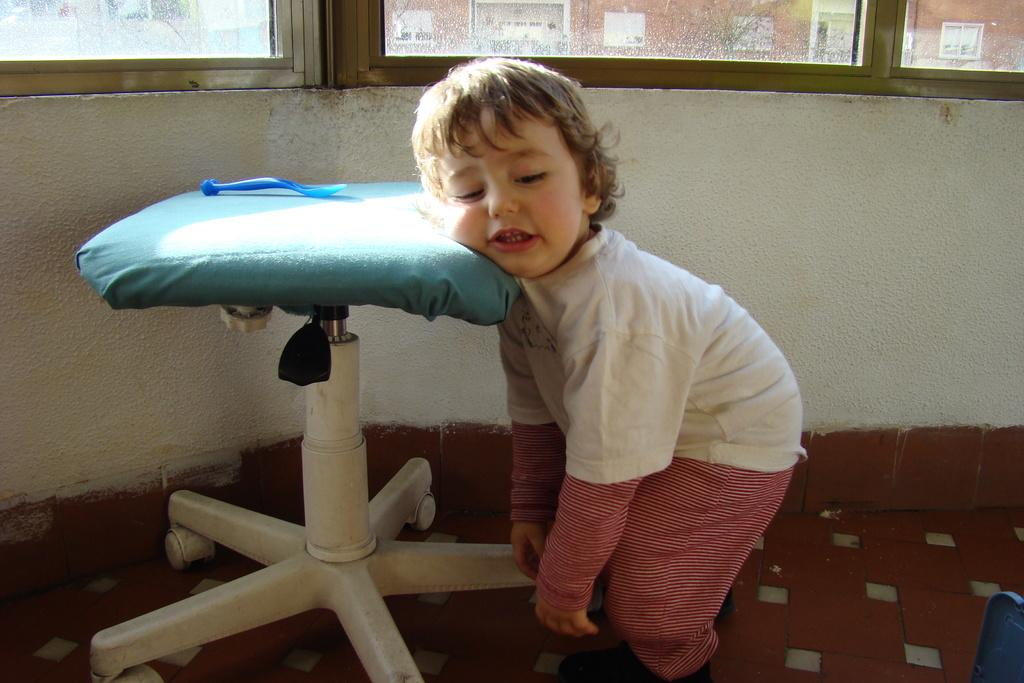What is the main subject of the image? There is a small baby in the image. What object can be seen in the image besides the baby? There is a table in the image. What can be seen in the background of the image? There are windows visible in the background of the image. What type of ant can be seen crawling on the baby's cap in the image? There is no ant or cap present in the image; the main subject is a small baby, and there are no other accessories mentioned. 